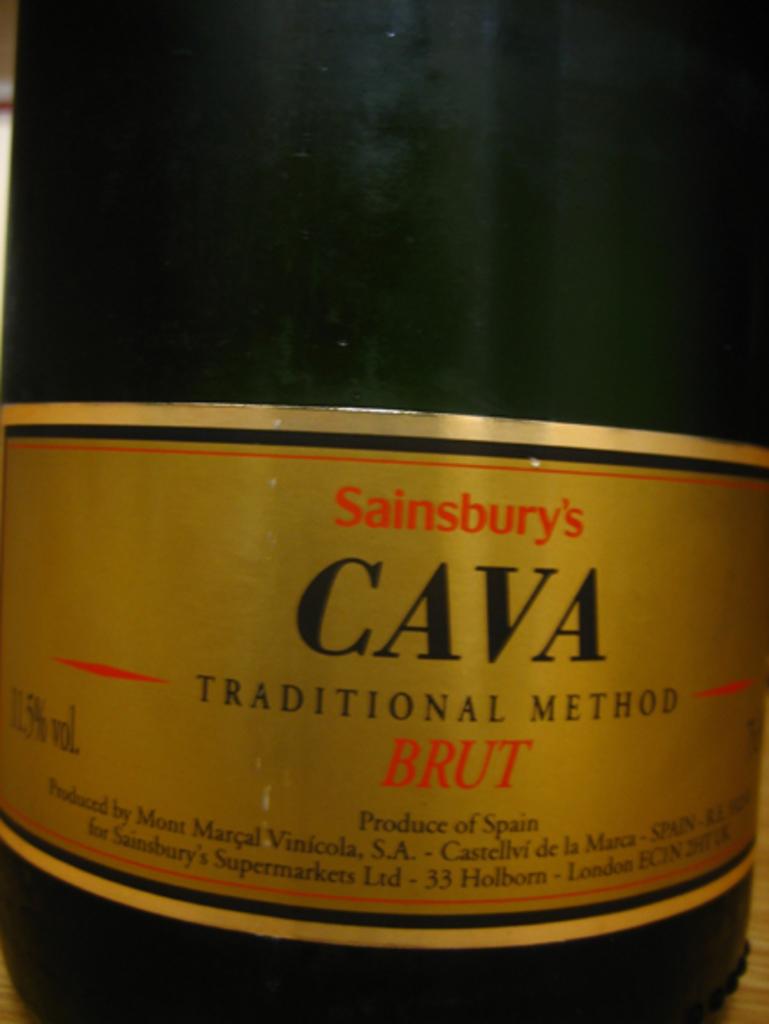Who is the manufacturer of this wine?
Ensure brevity in your answer.  Sainsbury. 